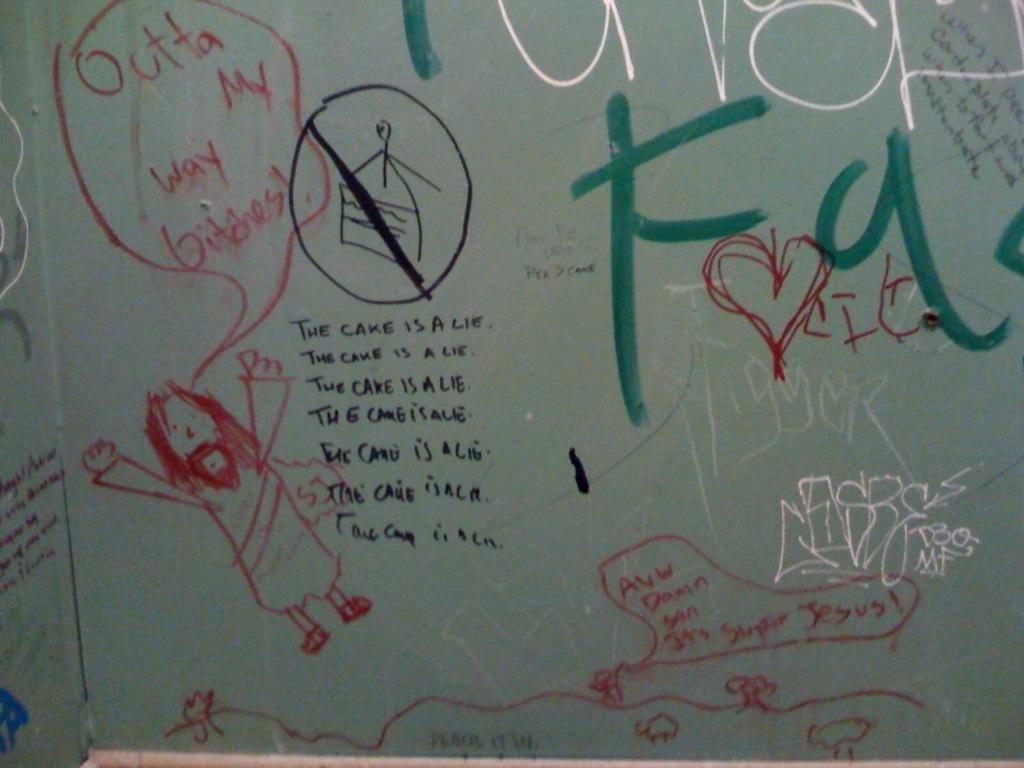What is a lie according to the image?
Offer a terse response. The cake. 